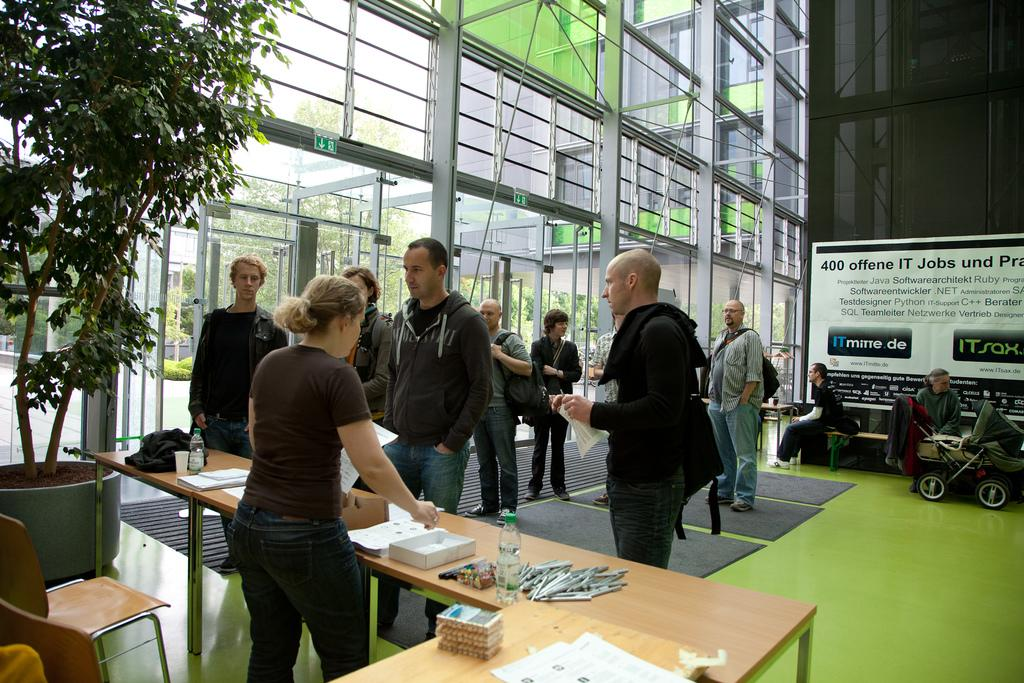How many people are in the room in the image? There are many people in the room in the image. What is one of the main objects in the room? There is a table in the room. What type of vegetation is present in the room? There is a big plant in the room. What type of distribution system is present in the room? There is no distribution system present in the room; the image only shows people, a table, and a big plant. Is there a shop in the room? There is no shop present in the room; the image only shows people, a table, and a big plant. 